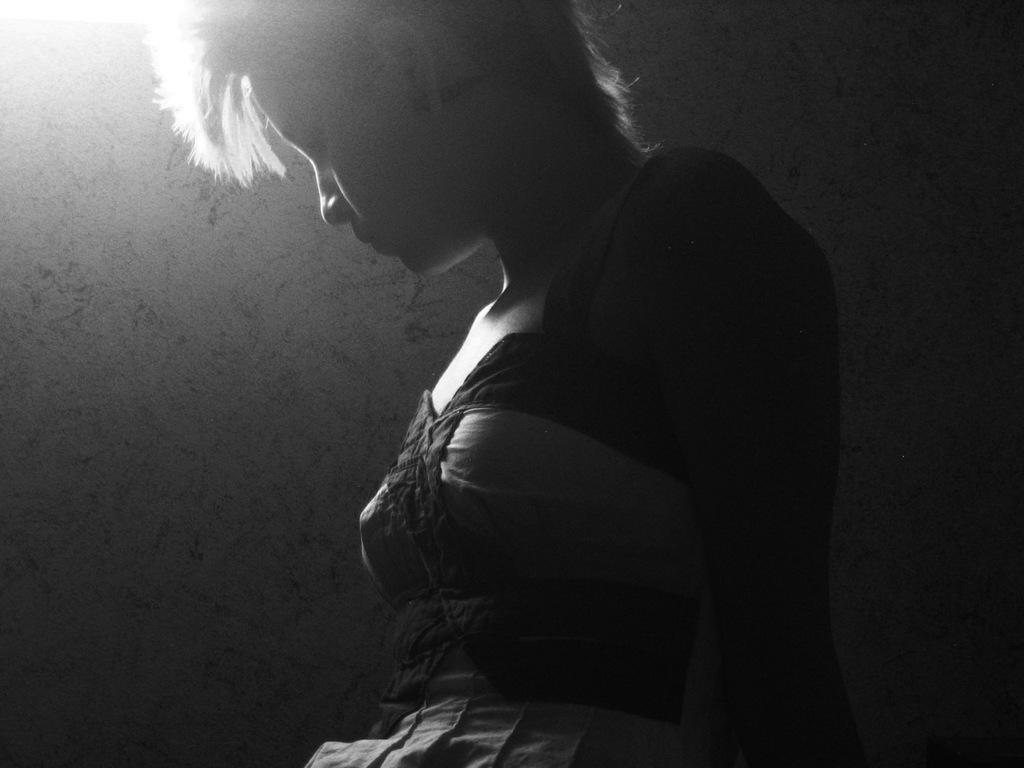Who is present in the image? There is a woman in the image. What is the woman wearing? The woman is wearing a black dress. Where is the woman located in the image? The woman is standing near a wall. What type of news can be heard coming from the cows in the image? There are no cows present in the image, so it's not possible to determine what, if any, news might be heard. 